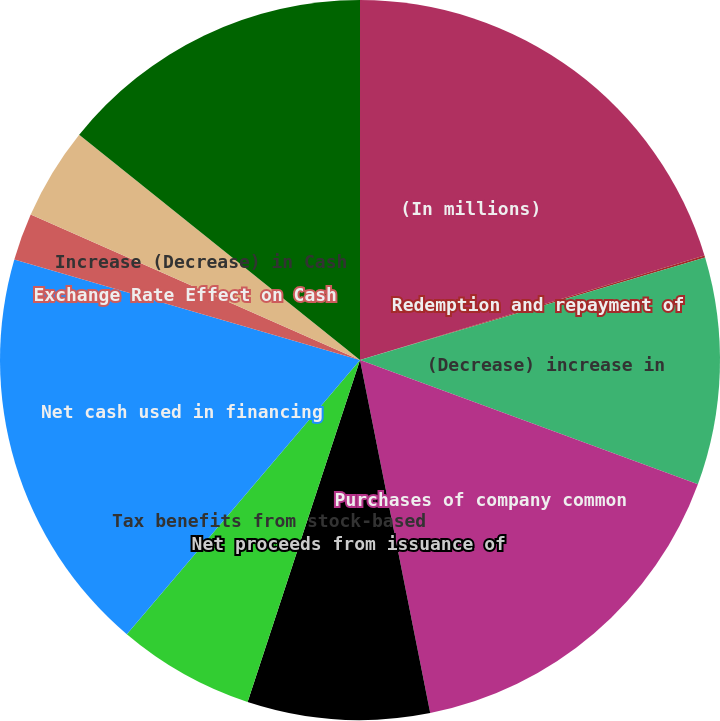<chart> <loc_0><loc_0><loc_500><loc_500><pie_chart><fcel>(In millions)<fcel>Redemption and repayment of<fcel>(Decrease) increase in<fcel>Purchases of company common<fcel>Net proceeds from issuance of<fcel>Tax benefits from stock-based<fcel>Net cash used in financing<fcel>Exchange Rate Effect on Cash<fcel>Increase (Decrease) in Cash<fcel>Cash and Cash Equivalents at<nl><fcel>20.31%<fcel>0.1%<fcel>10.2%<fcel>16.27%<fcel>8.18%<fcel>6.16%<fcel>18.29%<fcel>2.12%<fcel>4.14%<fcel>14.24%<nl></chart> 